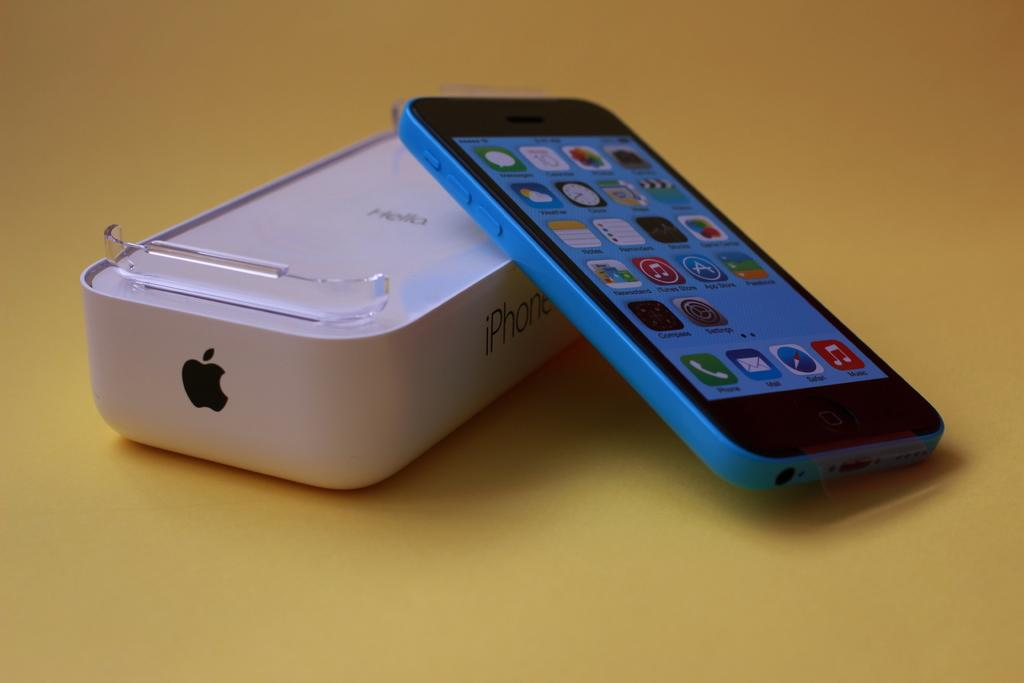<image>
Describe the image concisely. a phone with the word phone located on the phone icon 